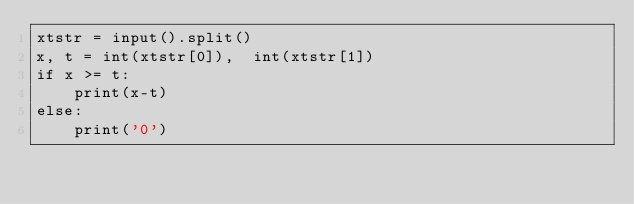Convert code to text. <code><loc_0><loc_0><loc_500><loc_500><_Python_>xtstr = input().split()
x, t = int(xtstr[0]),  int(xtstr[1])
if x >= t:
    print(x-t)
else:
    print('0')</code> 